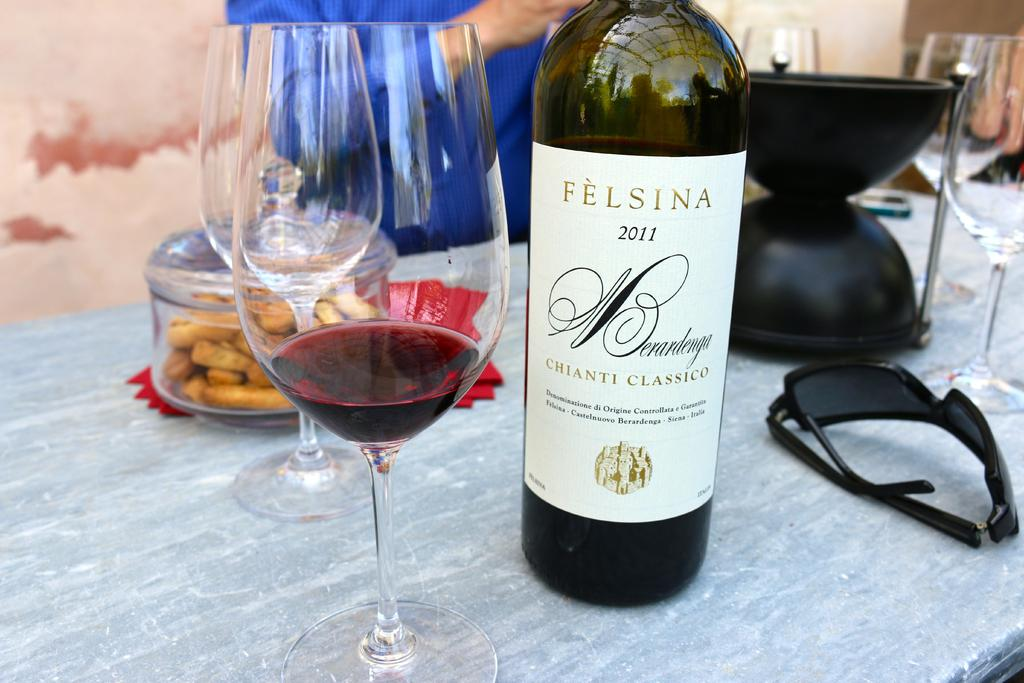<image>
Create a compact narrative representing the image presented. A table with wine glasses and a 2011 Felsina wine. 